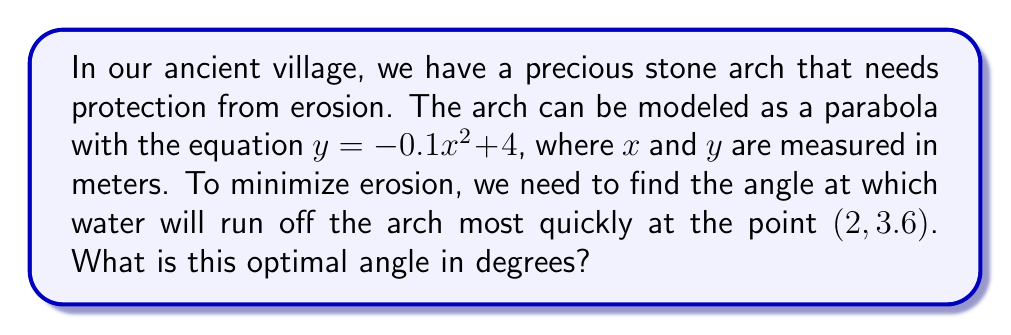Provide a solution to this math problem. To find the optimal angle for water runoff, we need to calculate the angle of the tangent line to the parabola at the given point. Here's how we can do this:

1) The general equation of the parabola is $y = -0.1x^2 + 4$

2) To find the slope of the tangent line, we need to differentiate the equation:
   $$\frac{dy}{dx} = -0.2x$$

3) At the point (2, 3.6), the slope is:
   $$\frac{dy}{dx}|_{x=2} = -0.2(2) = -0.4$$

4) The angle of the tangent line with respect to the horizontal is given by:
   $$\theta = \arctan(-0.4)$$

5) Convert this angle from radians to degrees:
   $$\theta = \arctan(-0.4) \cdot \frac{180}{\pi}$$

6) Calculate the result:
   $$\theta \approx -21.80^\circ$$

7) However, we want the angle with respect to the vertical, not the horizontal. To get this, we subtract our result from 90°:
   $$90^\circ - (-21.80^\circ) = 111.80^\circ$$

Therefore, the optimal angle for water runoff is approximately 111.80° from the vertical.
Answer: $111.80^\circ$ 